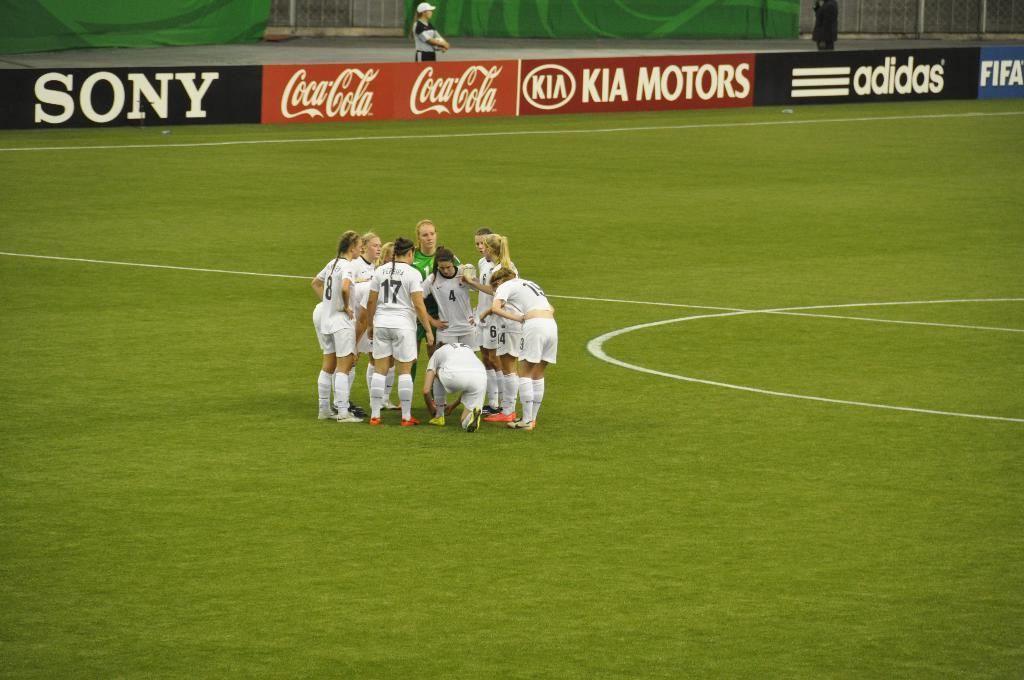What is happening in the image? There are people on the ground in the image. What can be seen in the background of the image? There are banners with text in the background of the image. How many deer are visible in the image? There are no deer present in the image. What type of drink is being served at the event in the image? There is no event or drink visible in the image; it only shows people on the ground and banners with text in the background. 